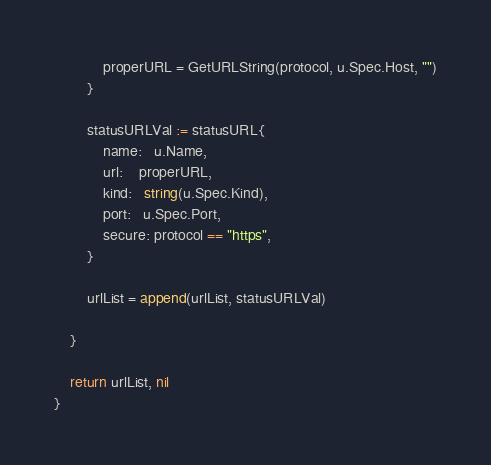<code> <loc_0><loc_0><loc_500><loc_500><_Go_>			properURL = GetURLString(protocol, u.Spec.Host, "")
		}

		statusURLVal := statusURL{
			name:   u.Name,
			url:    properURL,
			kind:   string(u.Spec.Kind),
			port:   u.Spec.Port,
			secure: protocol == "https",
		}

		urlList = append(urlList, statusURLVal)

	}

	return urlList, nil
}
</code> 